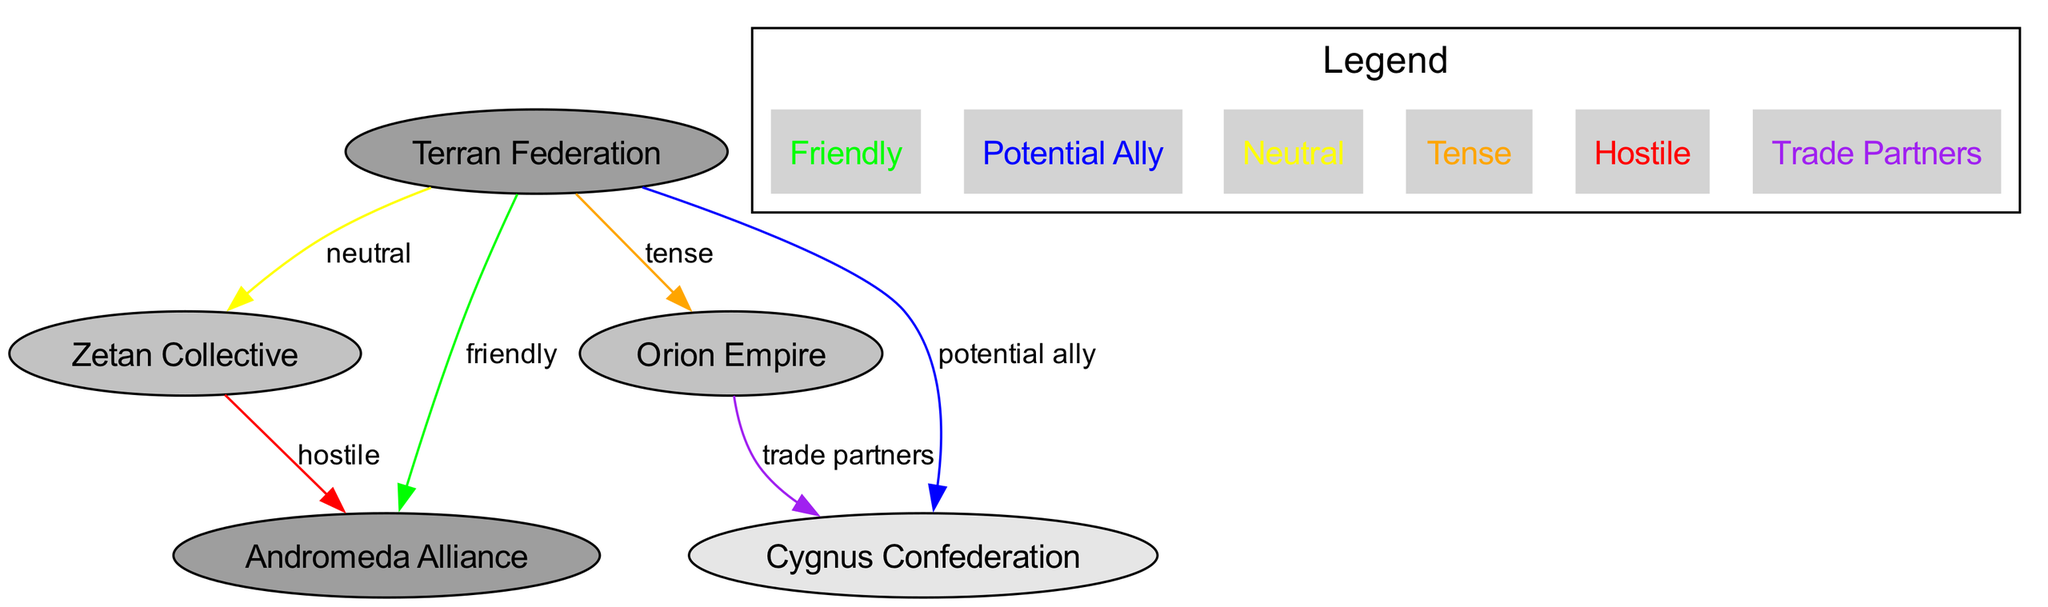What is the relationship status between the Terran Federation and the Zetan Collective? The relationship status is indicated by the edge connecting the two nodes, which is marked with the color yellow. According to the legend, yellow represents a neutral relationship.
Answer: Neutral How many civilizations are represented in the diagram? The diagram lists five civilizations in total: Terran Federation, Zetan Collective, Andromeda Alliance, Orion Empire, and Cygnus Confederation. Counting these gives a total of five nodes.
Answer: 5 What is the influence level of the Cygnus Confederation? The influence level is specified next to each civilization, and for Cygnus Confederation, it is labeled as low.
Answer: Low Which civilization has a friendly relationship with the Terran Federation? The relationship with the Andromeda Alliance is marked green, indicating a friendly status. By checking the relationship edges, it’s determined that Andromeda Alliance is the one with a friendly connection to the Terran Federation.
Answer: Andromeda Alliance Which civilization is located to the east of the Terran Federation? The diagram displays the positions of each civilization relative to the Terran Federation. The Andromeda Alliance is indicated to be on the right side, which corresponds to the east.
Answer: Andromeda Alliance What color indicates a hostile relationship in the diagram? The legend outlines the meanings of each color used for the relationships. It clearly states that the color red signifies a hostile relationship. By searching for where the hostility is indicated, we observe the edge between the Zetan Collective and the Andromeda Alliance is red.
Answer: Red Which two civilizations are identified as trade partners? The relationship status between the Orion Empire and Cygnus Confederation is expressed using the color purple. According to the legend, purple indicates trade partners, thus these two civilizations have this specific relationship.
Answer: Orion Empire and Cygnus Confederation Is the Zetan Collective a potential ally for the Terran Federation? The edge connecting the Terran Federation and the Zetan Collective is colored yellow, which denotes a neutral relationship according to the legend. Since potential allies are specifically marked with blue, the Zetan Collective does not hold this status.
Answer: No How many relationship types are shown in the diagram? The relationships illustrated in the diagram represent various types of interactions. The relationships consist of neutral, friendly, tense, potential ally, hostile, and trade partners, totaling six different types.
Answer: 6 